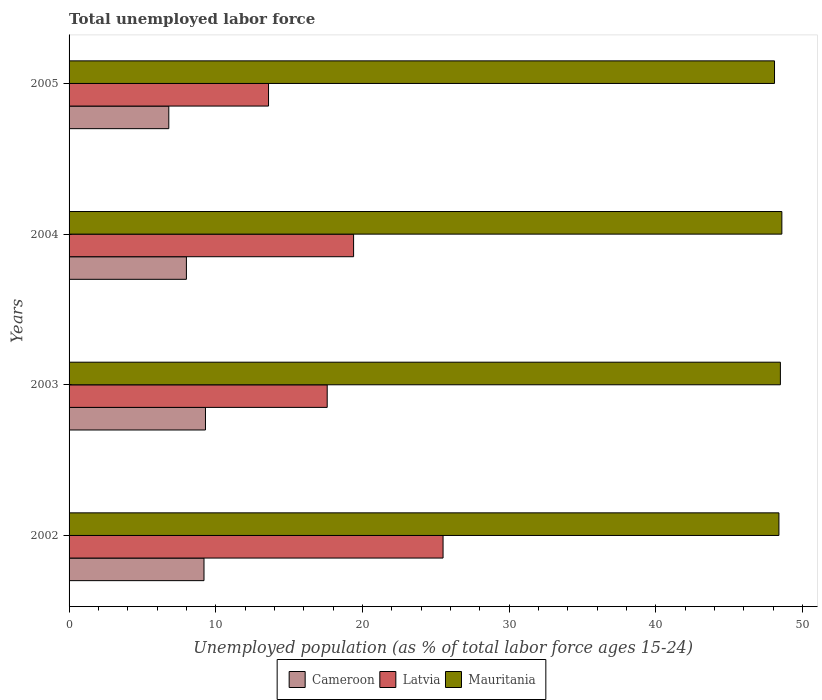How many different coloured bars are there?
Offer a very short reply. 3. How many groups of bars are there?
Your answer should be very brief. 4. Are the number of bars per tick equal to the number of legend labels?
Your answer should be compact. Yes. What is the label of the 1st group of bars from the top?
Ensure brevity in your answer.  2005. What is the percentage of unemployed population in in Cameroon in 2004?
Make the answer very short. 8. Across all years, what is the maximum percentage of unemployed population in in Mauritania?
Provide a short and direct response. 48.6. Across all years, what is the minimum percentage of unemployed population in in Mauritania?
Ensure brevity in your answer.  48.1. In which year was the percentage of unemployed population in in Latvia maximum?
Keep it short and to the point. 2002. What is the total percentage of unemployed population in in Latvia in the graph?
Your answer should be very brief. 76.1. What is the difference between the percentage of unemployed population in in Latvia in 2002 and that in 2005?
Offer a terse response. 11.9. What is the difference between the percentage of unemployed population in in Mauritania in 2004 and the percentage of unemployed population in in Latvia in 2005?
Your answer should be compact. 35. What is the average percentage of unemployed population in in Mauritania per year?
Your response must be concise. 48.4. In the year 2003, what is the difference between the percentage of unemployed population in in Cameroon and percentage of unemployed population in in Latvia?
Your answer should be compact. -8.3. What is the ratio of the percentage of unemployed population in in Mauritania in 2003 to that in 2004?
Make the answer very short. 1. What is the difference between the highest and the second highest percentage of unemployed population in in Mauritania?
Your response must be concise. 0.1. What is the difference between the highest and the lowest percentage of unemployed population in in Latvia?
Your answer should be compact. 11.9. What does the 3rd bar from the top in 2003 represents?
Ensure brevity in your answer.  Cameroon. What does the 2nd bar from the bottom in 2002 represents?
Offer a terse response. Latvia. How many bars are there?
Keep it short and to the point. 12. Are all the bars in the graph horizontal?
Keep it short and to the point. Yes. What is the difference between two consecutive major ticks on the X-axis?
Your answer should be compact. 10. Does the graph contain any zero values?
Your answer should be compact. No. Where does the legend appear in the graph?
Keep it short and to the point. Bottom center. How are the legend labels stacked?
Your answer should be very brief. Horizontal. What is the title of the graph?
Provide a succinct answer. Total unemployed labor force. Does "Armenia" appear as one of the legend labels in the graph?
Your response must be concise. No. What is the label or title of the X-axis?
Offer a very short reply. Unemployed population (as % of total labor force ages 15-24). What is the label or title of the Y-axis?
Keep it short and to the point. Years. What is the Unemployed population (as % of total labor force ages 15-24) in Cameroon in 2002?
Your response must be concise. 9.2. What is the Unemployed population (as % of total labor force ages 15-24) in Mauritania in 2002?
Provide a succinct answer. 48.4. What is the Unemployed population (as % of total labor force ages 15-24) of Cameroon in 2003?
Provide a succinct answer. 9.3. What is the Unemployed population (as % of total labor force ages 15-24) of Latvia in 2003?
Your answer should be very brief. 17.6. What is the Unemployed population (as % of total labor force ages 15-24) in Mauritania in 2003?
Give a very brief answer. 48.5. What is the Unemployed population (as % of total labor force ages 15-24) in Latvia in 2004?
Provide a succinct answer. 19.4. What is the Unemployed population (as % of total labor force ages 15-24) of Mauritania in 2004?
Provide a succinct answer. 48.6. What is the Unemployed population (as % of total labor force ages 15-24) of Cameroon in 2005?
Offer a terse response. 6.8. What is the Unemployed population (as % of total labor force ages 15-24) in Latvia in 2005?
Your answer should be compact. 13.6. What is the Unemployed population (as % of total labor force ages 15-24) of Mauritania in 2005?
Give a very brief answer. 48.1. Across all years, what is the maximum Unemployed population (as % of total labor force ages 15-24) of Cameroon?
Offer a very short reply. 9.3. Across all years, what is the maximum Unemployed population (as % of total labor force ages 15-24) of Mauritania?
Your answer should be very brief. 48.6. Across all years, what is the minimum Unemployed population (as % of total labor force ages 15-24) in Cameroon?
Offer a terse response. 6.8. Across all years, what is the minimum Unemployed population (as % of total labor force ages 15-24) of Latvia?
Your answer should be very brief. 13.6. Across all years, what is the minimum Unemployed population (as % of total labor force ages 15-24) in Mauritania?
Make the answer very short. 48.1. What is the total Unemployed population (as % of total labor force ages 15-24) of Cameroon in the graph?
Ensure brevity in your answer.  33.3. What is the total Unemployed population (as % of total labor force ages 15-24) in Latvia in the graph?
Keep it short and to the point. 76.1. What is the total Unemployed population (as % of total labor force ages 15-24) of Mauritania in the graph?
Give a very brief answer. 193.6. What is the difference between the Unemployed population (as % of total labor force ages 15-24) of Mauritania in 2002 and that in 2003?
Your response must be concise. -0.1. What is the difference between the Unemployed population (as % of total labor force ages 15-24) in Mauritania in 2002 and that in 2004?
Ensure brevity in your answer.  -0.2. What is the difference between the Unemployed population (as % of total labor force ages 15-24) in Cameroon in 2002 and that in 2005?
Provide a short and direct response. 2.4. What is the difference between the Unemployed population (as % of total labor force ages 15-24) in Latvia in 2002 and that in 2005?
Offer a terse response. 11.9. What is the difference between the Unemployed population (as % of total labor force ages 15-24) in Mauritania in 2002 and that in 2005?
Your response must be concise. 0.3. What is the difference between the Unemployed population (as % of total labor force ages 15-24) in Latvia in 2003 and that in 2004?
Offer a very short reply. -1.8. What is the difference between the Unemployed population (as % of total labor force ages 15-24) of Cameroon in 2004 and that in 2005?
Make the answer very short. 1.2. What is the difference between the Unemployed population (as % of total labor force ages 15-24) in Cameroon in 2002 and the Unemployed population (as % of total labor force ages 15-24) in Latvia in 2003?
Your answer should be compact. -8.4. What is the difference between the Unemployed population (as % of total labor force ages 15-24) in Cameroon in 2002 and the Unemployed population (as % of total labor force ages 15-24) in Mauritania in 2003?
Make the answer very short. -39.3. What is the difference between the Unemployed population (as % of total labor force ages 15-24) in Latvia in 2002 and the Unemployed population (as % of total labor force ages 15-24) in Mauritania in 2003?
Your response must be concise. -23. What is the difference between the Unemployed population (as % of total labor force ages 15-24) of Cameroon in 2002 and the Unemployed population (as % of total labor force ages 15-24) of Mauritania in 2004?
Give a very brief answer. -39.4. What is the difference between the Unemployed population (as % of total labor force ages 15-24) of Latvia in 2002 and the Unemployed population (as % of total labor force ages 15-24) of Mauritania in 2004?
Give a very brief answer. -23.1. What is the difference between the Unemployed population (as % of total labor force ages 15-24) of Cameroon in 2002 and the Unemployed population (as % of total labor force ages 15-24) of Latvia in 2005?
Keep it short and to the point. -4.4. What is the difference between the Unemployed population (as % of total labor force ages 15-24) in Cameroon in 2002 and the Unemployed population (as % of total labor force ages 15-24) in Mauritania in 2005?
Offer a very short reply. -38.9. What is the difference between the Unemployed population (as % of total labor force ages 15-24) of Latvia in 2002 and the Unemployed population (as % of total labor force ages 15-24) of Mauritania in 2005?
Your answer should be very brief. -22.6. What is the difference between the Unemployed population (as % of total labor force ages 15-24) in Cameroon in 2003 and the Unemployed population (as % of total labor force ages 15-24) in Mauritania in 2004?
Your answer should be compact. -39.3. What is the difference between the Unemployed population (as % of total labor force ages 15-24) of Latvia in 2003 and the Unemployed population (as % of total labor force ages 15-24) of Mauritania in 2004?
Ensure brevity in your answer.  -31. What is the difference between the Unemployed population (as % of total labor force ages 15-24) of Cameroon in 2003 and the Unemployed population (as % of total labor force ages 15-24) of Mauritania in 2005?
Your response must be concise. -38.8. What is the difference between the Unemployed population (as % of total labor force ages 15-24) in Latvia in 2003 and the Unemployed population (as % of total labor force ages 15-24) in Mauritania in 2005?
Ensure brevity in your answer.  -30.5. What is the difference between the Unemployed population (as % of total labor force ages 15-24) of Cameroon in 2004 and the Unemployed population (as % of total labor force ages 15-24) of Mauritania in 2005?
Keep it short and to the point. -40.1. What is the difference between the Unemployed population (as % of total labor force ages 15-24) in Latvia in 2004 and the Unemployed population (as % of total labor force ages 15-24) in Mauritania in 2005?
Offer a very short reply. -28.7. What is the average Unemployed population (as % of total labor force ages 15-24) of Cameroon per year?
Offer a very short reply. 8.32. What is the average Unemployed population (as % of total labor force ages 15-24) of Latvia per year?
Your answer should be compact. 19.02. What is the average Unemployed population (as % of total labor force ages 15-24) of Mauritania per year?
Provide a succinct answer. 48.4. In the year 2002, what is the difference between the Unemployed population (as % of total labor force ages 15-24) of Cameroon and Unemployed population (as % of total labor force ages 15-24) of Latvia?
Provide a short and direct response. -16.3. In the year 2002, what is the difference between the Unemployed population (as % of total labor force ages 15-24) of Cameroon and Unemployed population (as % of total labor force ages 15-24) of Mauritania?
Offer a terse response. -39.2. In the year 2002, what is the difference between the Unemployed population (as % of total labor force ages 15-24) in Latvia and Unemployed population (as % of total labor force ages 15-24) in Mauritania?
Your answer should be compact. -22.9. In the year 2003, what is the difference between the Unemployed population (as % of total labor force ages 15-24) in Cameroon and Unemployed population (as % of total labor force ages 15-24) in Mauritania?
Your answer should be very brief. -39.2. In the year 2003, what is the difference between the Unemployed population (as % of total labor force ages 15-24) in Latvia and Unemployed population (as % of total labor force ages 15-24) in Mauritania?
Your answer should be very brief. -30.9. In the year 2004, what is the difference between the Unemployed population (as % of total labor force ages 15-24) of Cameroon and Unemployed population (as % of total labor force ages 15-24) of Latvia?
Keep it short and to the point. -11.4. In the year 2004, what is the difference between the Unemployed population (as % of total labor force ages 15-24) in Cameroon and Unemployed population (as % of total labor force ages 15-24) in Mauritania?
Offer a very short reply. -40.6. In the year 2004, what is the difference between the Unemployed population (as % of total labor force ages 15-24) in Latvia and Unemployed population (as % of total labor force ages 15-24) in Mauritania?
Ensure brevity in your answer.  -29.2. In the year 2005, what is the difference between the Unemployed population (as % of total labor force ages 15-24) in Cameroon and Unemployed population (as % of total labor force ages 15-24) in Latvia?
Ensure brevity in your answer.  -6.8. In the year 2005, what is the difference between the Unemployed population (as % of total labor force ages 15-24) of Cameroon and Unemployed population (as % of total labor force ages 15-24) of Mauritania?
Provide a succinct answer. -41.3. In the year 2005, what is the difference between the Unemployed population (as % of total labor force ages 15-24) in Latvia and Unemployed population (as % of total labor force ages 15-24) in Mauritania?
Your response must be concise. -34.5. What is the ratio of the Unemployed population (as % of total labor force ages 15-24) of Latvia in 2002 to that in 2003?
Make the answer very short. 1.45. What is the ratio of the Unemployed population (as % of total labor force ages 15-24) of Mauritania in 2002 to that in 2003?
Your answer should be very brief. 1. What is the ratio of the Unemployed population (as % of total labor force ages 15-24) of Cameroon in 2002 to that in 2004?
Provide a short and direct response. 1.15. What is the ratio of the Unemployed population (as % of total labor force ages 15-24) in Latvia in 2002 to that in 2004?
Provide a succinct answer. 1.31. What is the ratio of the Unemployed population (as % of total labor force ages 15-24) in Mauritania in 2002 to that in 2004?
Your answer should be very brief. 1. What is the ratio of the Unemployed population (as % of total labor force ages 15-24) of Cameroon in 2002 to that in 2005?
Your response must be concise. 1.35. What is the ratio of the Unemployed population (as % of total labor force ages 15-24) in Latvia in 2002 to that in 2005?
Offer a terse response. 1.88. What is the ratio of the Unemployed population (as % of total labor force ages 15-24) of Cameroon in 2003 to that in 2004?
Offer a terse response. 1.16. What is the ratio of the Unemployed population (as % of total labor force ages 15-24) of Latvia in 2003 to that in 2004?
Offer a very short reply. 0.91. What is the ratio of the Unemployed population (as % of total labor force ages 15-24) of Mauritania in 2003 to that in 2004?
Provide a short and direct response. 1. What is the ratio of the Unemployed population (as % of total labor force ages 15-24) in Cameroon in 2003 to that in 2005?
Your response must be concise. 1.37. What is the ratio of the Unemployed population (as % of total labor force ages 15-24) in Latvia in 2003 to that in 2005?
Provide a short and direct response. 1.29. What is the ratio of the Unemployed population (as % of total labor force ages 15-24) in Mauritania in 2003 to that in 2005?
Give a very brief answer. 1.01. What is the ratio of the Unemployed population (as % of total labor force ages 15-24) of Cameroon in 2004 to that in 2005?
Provide a short and direct response. 1.18. What is the ratio of the Unemployed population (as % of total labor force ages 15-24) of Latvia in 2004 to that in 2005?
Ensure brevity in your answer.  1.43. What is the ratio of the Unemployed population (as % of total labor force ages 15-24) in Mauritania in 2004 to that in 2005?
Keep it short and to the point. 1.01. What is the difference between the highest and the second highest Unemployed population (as % of total labor force ages 15-24) in Mauritania?
Offer a terse response. 0.1. What is the difference between the highest and the lowest Unemployed population (as % of total labor force ages 15-24) in Cameroon?
Offer a terse response. 2.5. What is the difference between the highest and the lowest Unemployed population (as % of total labor force ages 15-24) of Latvia?
Give a very brief answer. 11.9. 